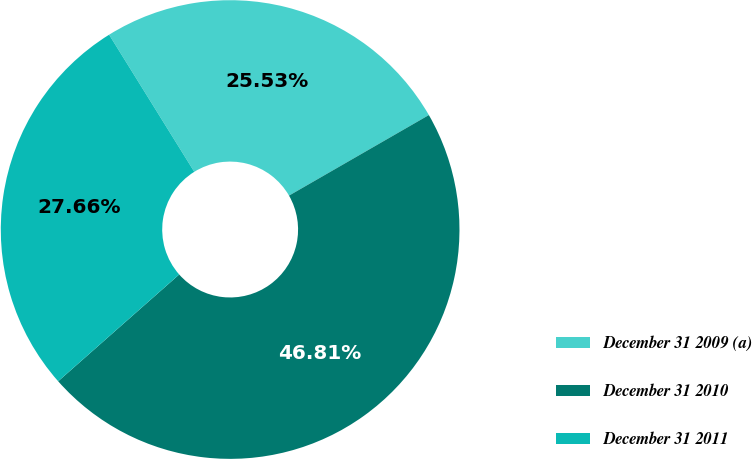Convert chart to OTSL. <chart><loc_0><loc_0><loc_500><loc_500><pie_chart><fcel>December 31 2009 (a)<fcel>December 31 2010<fcel>December 31 2011<nl><fcel>25.53%<fcel>46.81%<fcel>27.66%<nl></chart> 